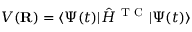Convert formula to latex. <formula><loc_0><loc_0><loc_500><loc_500>V ( { R } ) = \langle \Psi ( t ) | \hat { H } ^ { T C } | \Psi ( t ) \rangle</formula> 